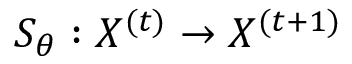<formula> <loc_0><loc_0><loc_500><loc_500>S _ { \theta } \colon X ^ { ( t ) } \rightarrow X ^ { ( t + 1 ) }</formula> 